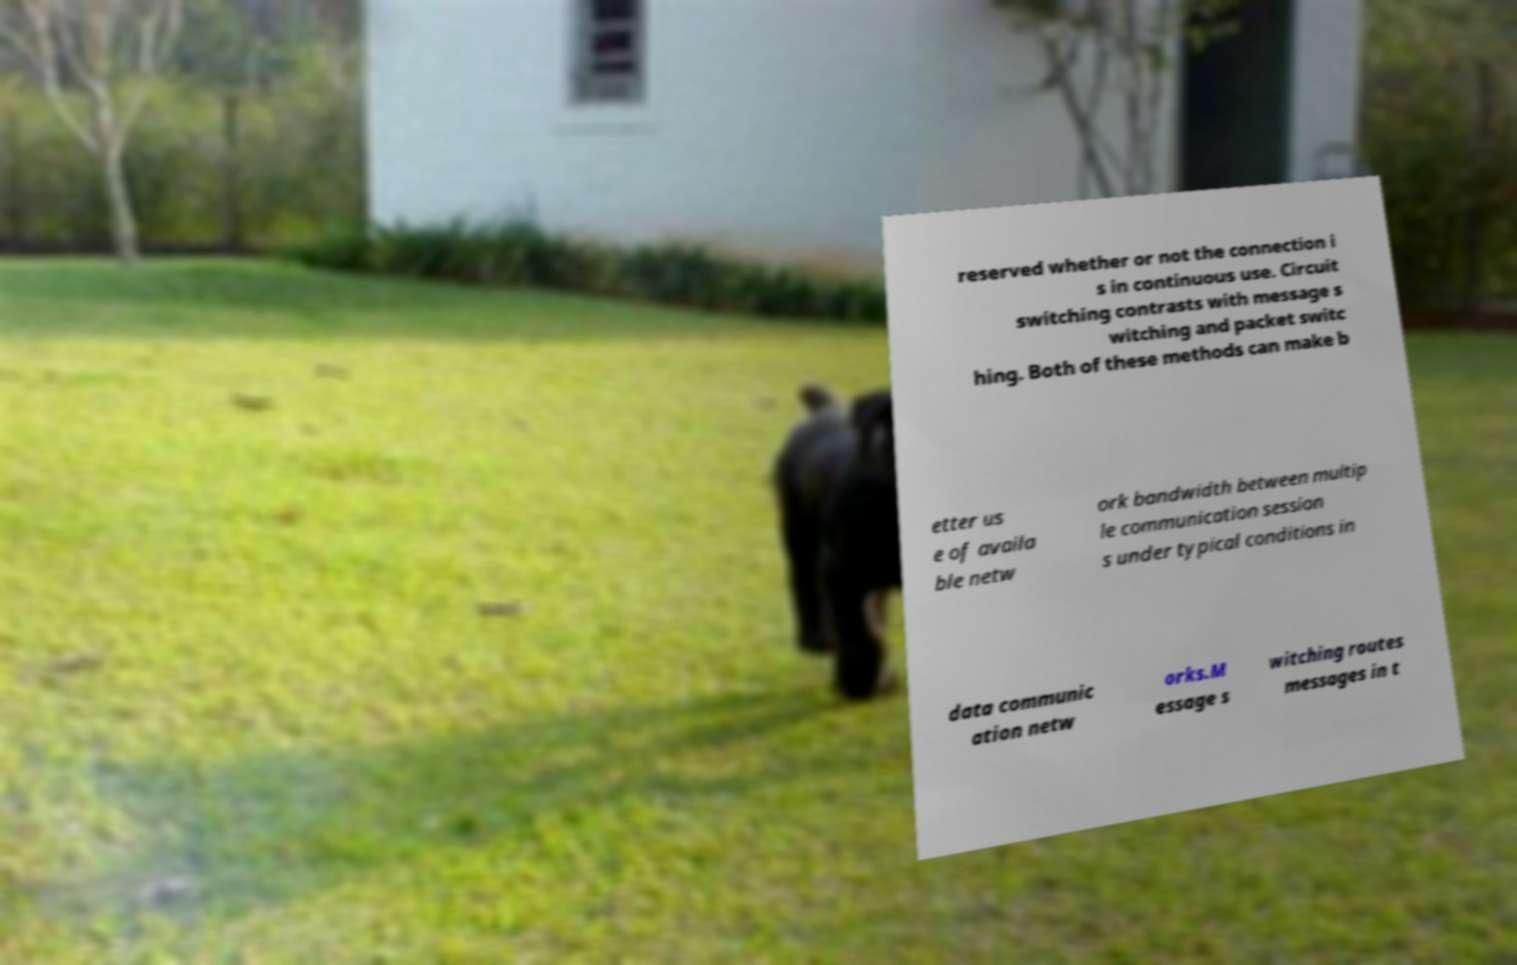Please identify and transcribe the text found in this image. reserved whether or not the connection i s in continuous use. Circuit switching contrasts with message s witching and packet switc hing. Both of these methods can make b etter us e of availa ble netw ork bandwidth between multip le communication session s under typical conditions in data communic ation netw orks.M essage s witching routes messages in t 